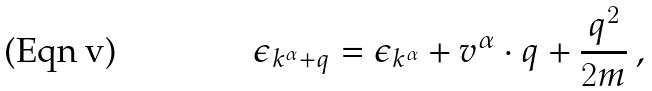<formula> <loc_0><loc_0><loc_500><loc_500>\epsilon _ { { k } ^ { \alpha } + { q } } = \epsilon _ { { k } ^ { \alpha } } + { v } ^ { \alpha } \cdot { q } + \frac { { q } ^ { 2 } } { 2 m } \, ,</formula> 